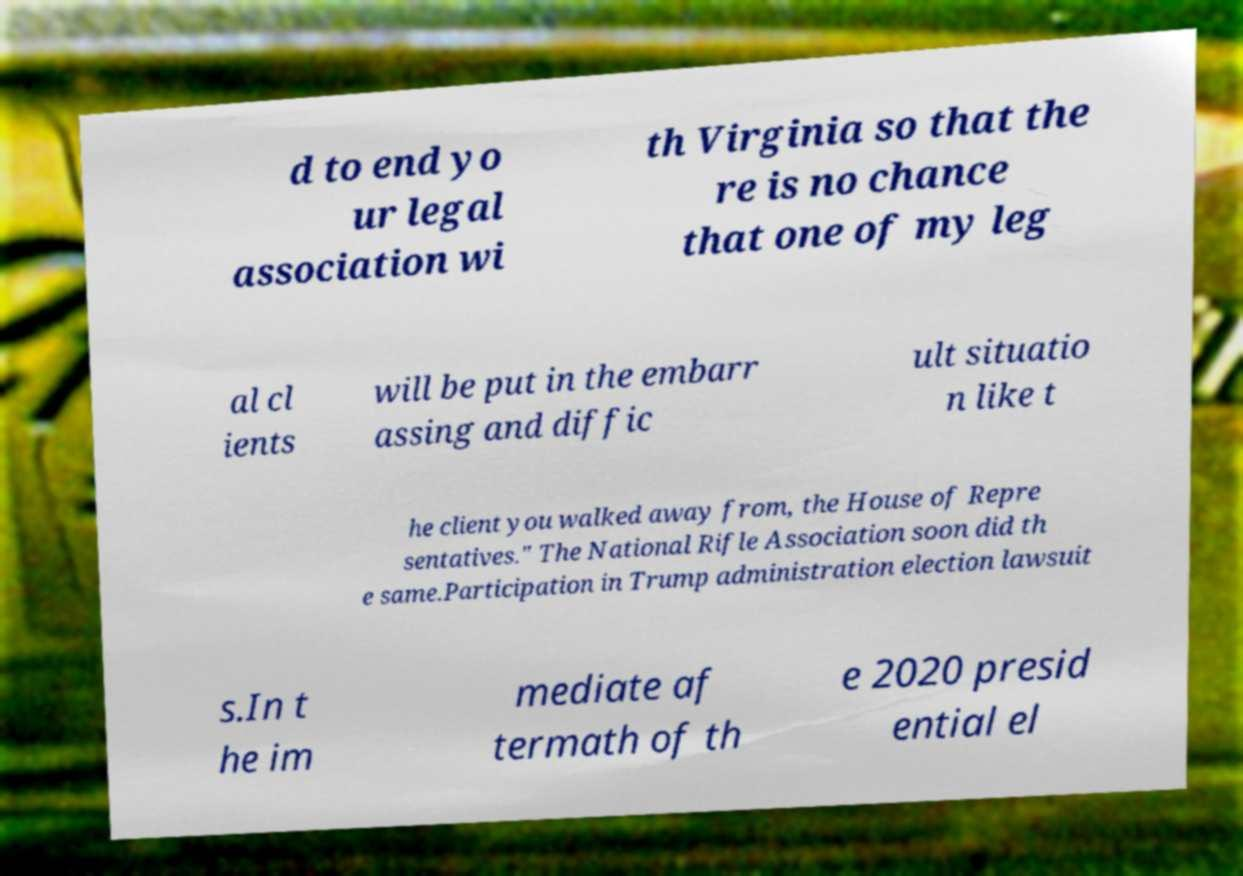Could you assist in decoding the text presented in this image and type it out clearly? d to end yo ur legal association wi th Virginia so that the re is no chance that one of my leg al cl ients will be put in the embarr assing and diffic ult situatio n like t he client you walked away from, the House of Repre sentatives." The National Rifle Association soon did th e same.Participation in Trump administration election lawsuit s.In t he im mediate af termath of th e 2020 presid ential el 